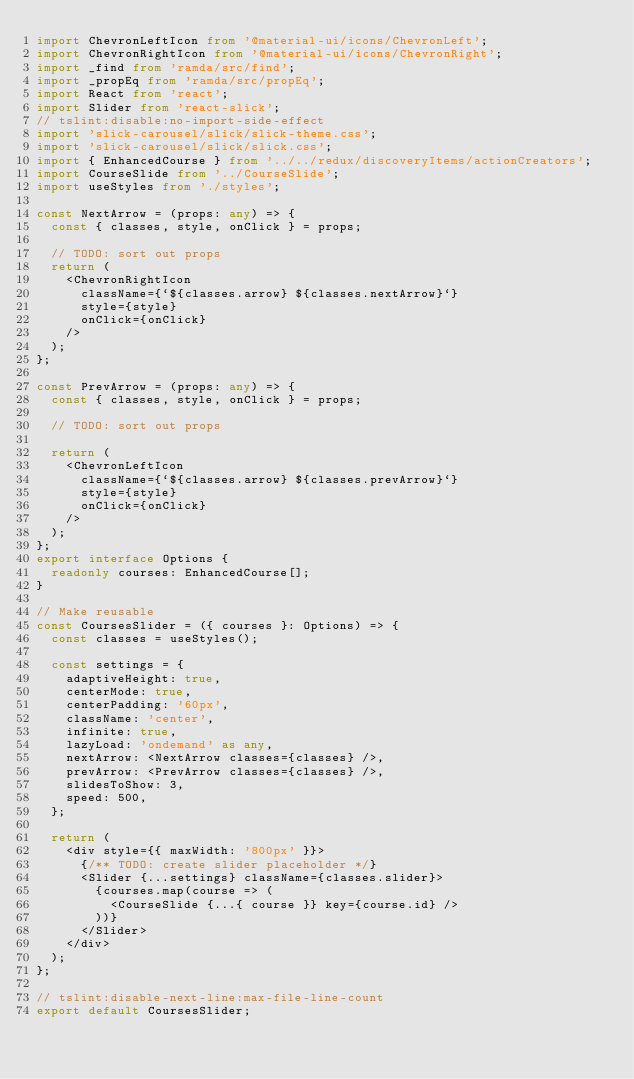Convert code to text. <code><loc_0><loc_0><loc_500><loc_500><_TypeScript_>import ChevronLeftIcon from '@material-ui/icons/ChevronLeft';
import ChevronRightIcon from '@material-ui/icons/ChevronRight';
import _find from 'ramda/src/find';
import _propEq from 'ramda/src/propEq';
import React from 'react';
import Slider from 'react-slick';
// tslint:disable:no-import-side-effect
import 'slick-carousel/slick/slick-theme.css';
import 'slick-carousel/slick/slick.css';
import { EnhancedCourse } from '../../redux/discoveryItems/actionCreators';
import CourseSlide from '../CourseSlide';
import useStyles from './styles';

const NextArrow = (props: any) => {
  const { classes, style, onClick } = props;

  // TODO: sort out props
  return (
    <ChevronRightIcon
      className={`${classes.arrow} ${classes.nextArrow}`}
      style={style}
      onClick={onClick}
    />
  );
};

const PrevArrow = (props: any) => {
  const { classes, style, onClick } = props;

  // TODO: sort out props

  return (
    <ChevronLeftIcon
      className={`${classes.arrow} ${classes.prevArrow}`}
      style={style}
      onClick={onClick}
    />
  );
};
export interface Options {
  readonly courses: EnhancedCourse[];
}

// Make reusable
const CoursesSlider = ({ courses }: Options) => {
  const classes = useStyles();

  const settings = {
    adaptiveHeight: true,
    centerMode: true,
    centerPadding: '60px',
    className: 'center',
    infinite: true,
    lazyLoad: 'ondemand' as any,
    nextArrow: <NextArrow classes={classes} />,
    prevArrow: <PrevArrow classes={classes} />,
    slidesToShow: 3,
    speed: 500,
  };

  return (
    <div style={{ maxWidth: '800px' }}>
      {/** TODO: create slider placeholder */}
      <Slider {...settings} className={classes.slider}>
        {courses.map(course => (
          <CourseSlide {...{ course }} key={course.id} />
        ))}
      </Slider>
    </div>
  );
};

// tslint:disable-next-line:max-file-line-count
export default CoursesSlider;
</code> 